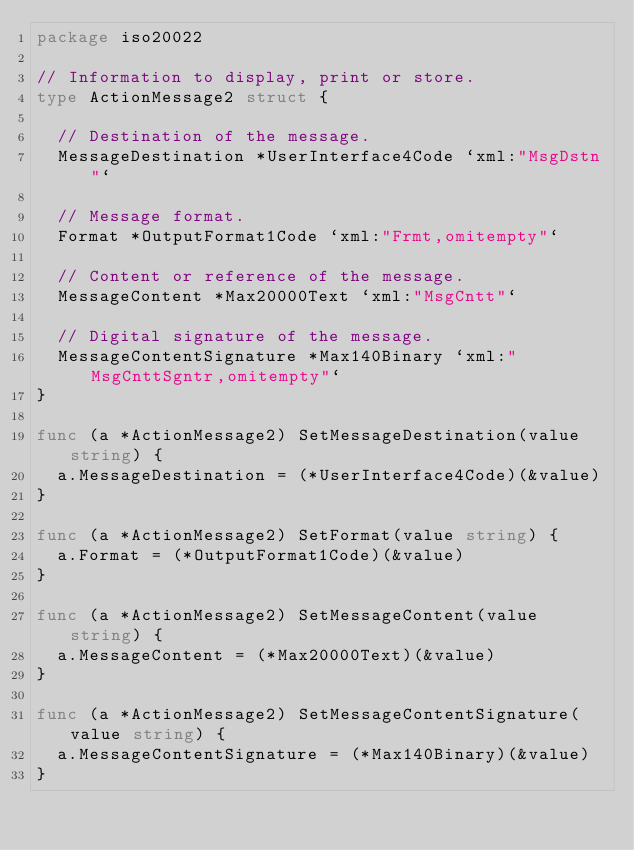<code> <loc_0><loc_0><loc_500><loc_500><_Go_>package iso20022

// Information to display, print or store.
type ActionMessage2 struct {

	// Destination of the message.
	MessageDestination *UserInterface4Code `xml:"MsgDstn"`

	// Message format.
	Format *OutputFormat1Code `xml:"Frmt,omitempty"`

	// Content or reference of the message.
	MessageContent *Max20000Text `xml:"MsgCntt"`

	// Digital signature of the message.
	MessageContentSignature *Max140Binary `xml:"MsgCnttSgntr,omitempty"`
}

func (a *ActionMessage2) SetMessageDestination(value string) {
	a.MessageDestination = (*UserInterface4Code)(&value)
}

func (a *ActionMessage2) SetFormat(value string) {
	a.Format = (*OutputFormat1Code)(&value)
}

func (a *ActionMessage2) SetMessageContent(value string) {
	a.MessageContent = (*Max20000Text)(&value)
}

func (a *ActionMessage2) SetMessageContentSignature(value string) {
	a.MessageContentSignature = (*Max140Binary)(&value)
}
</code> 